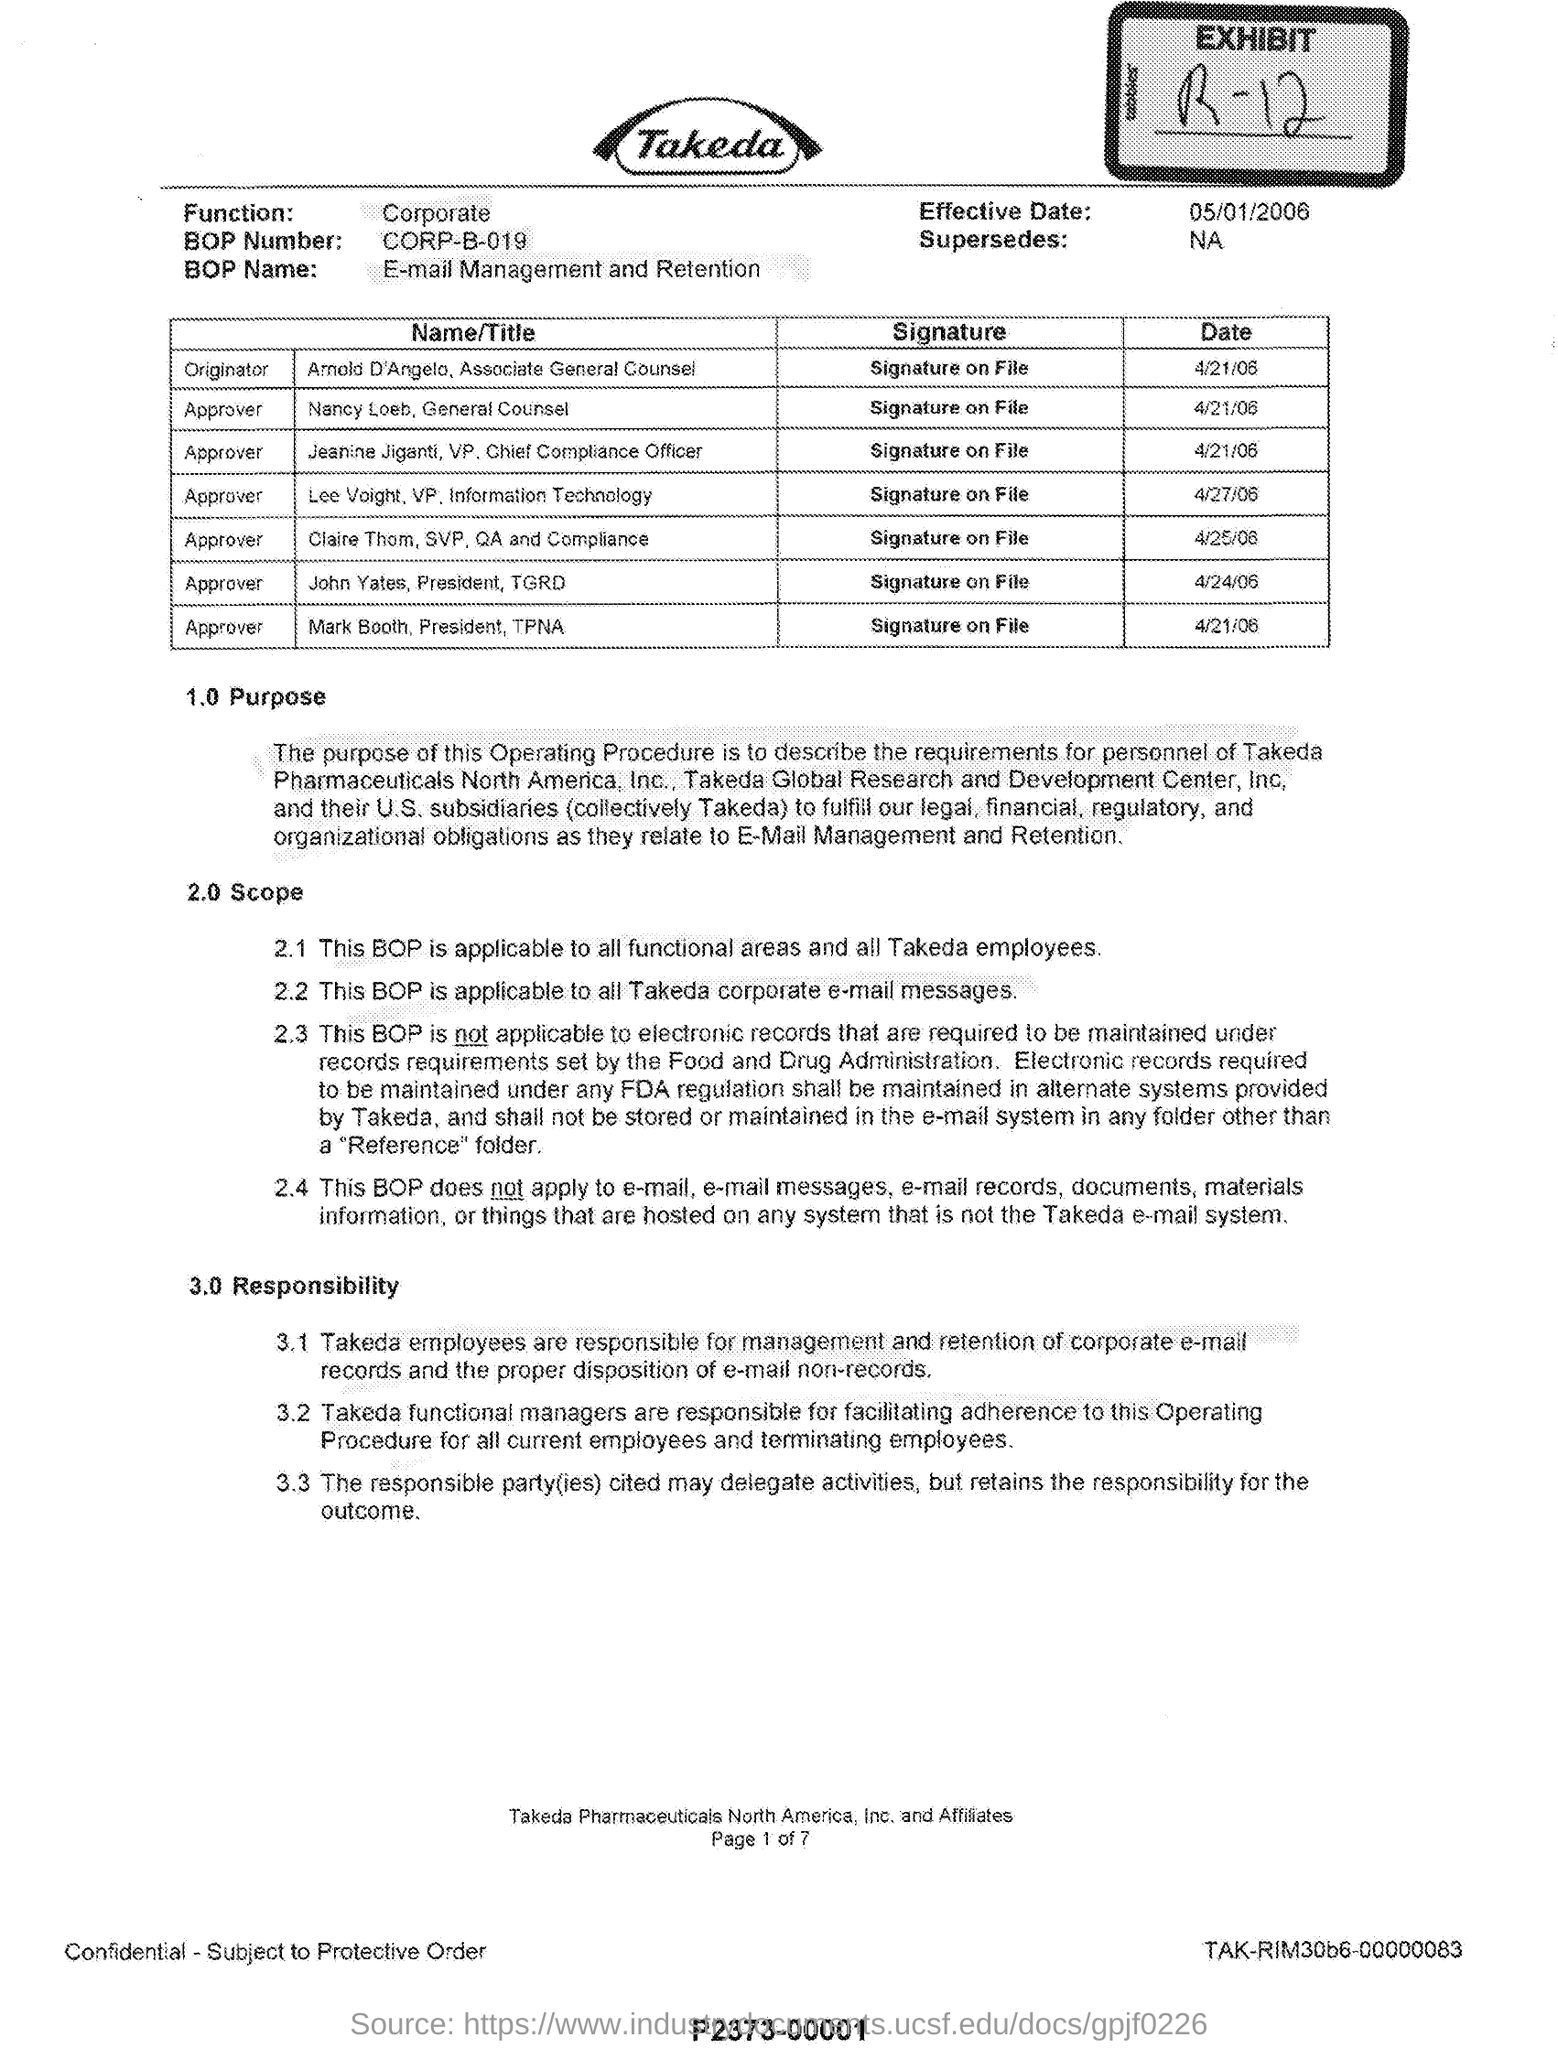Give some essential details in this illustration. The effective date of May 1, 2006, is the date upon which the specified action or event will take place. The BOP number is a unique identifier assigned to a document, such as CORP-B-019, which is used to manage and track its contents and metadata. What EXHIBIT number is mentioned? R-12... 